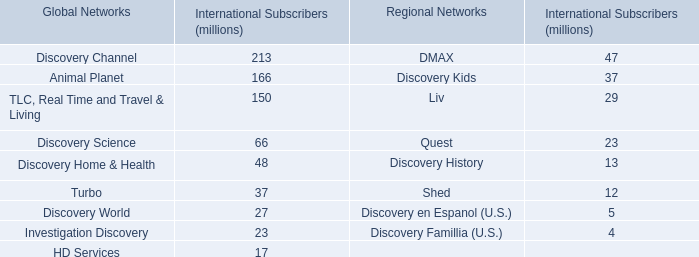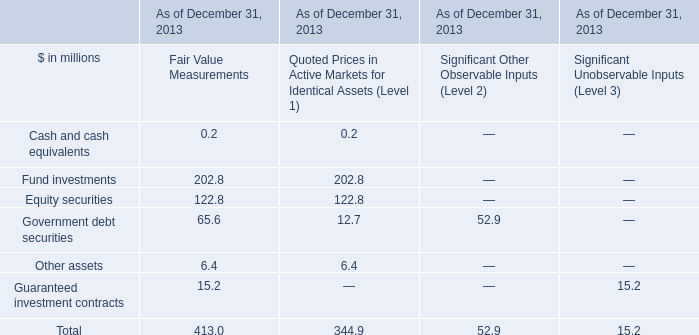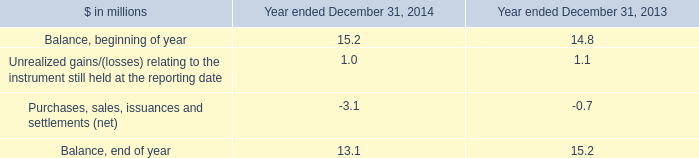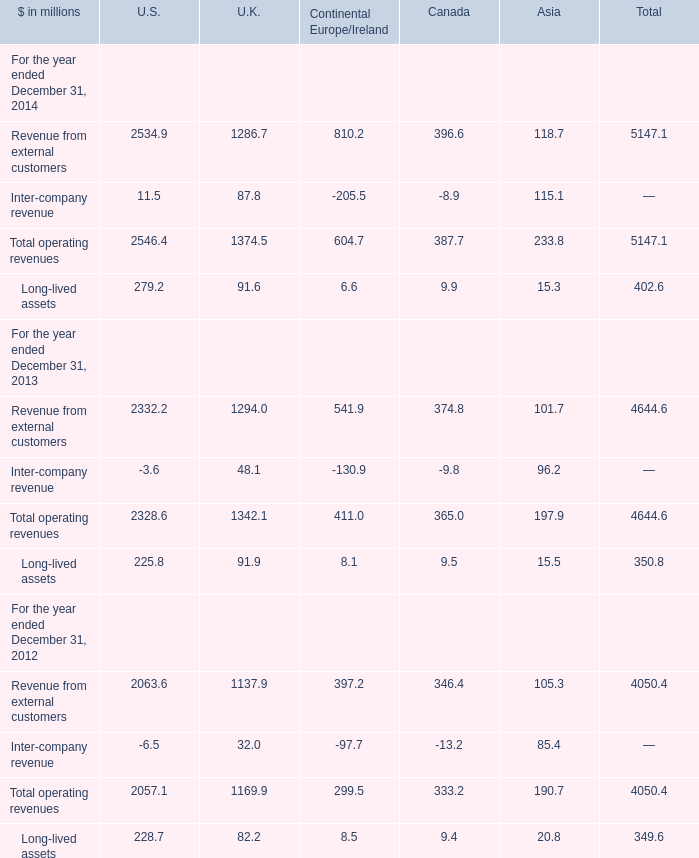Which year is Long-lived assets of Asia greater than 20 ? 
Answer: 2012. 